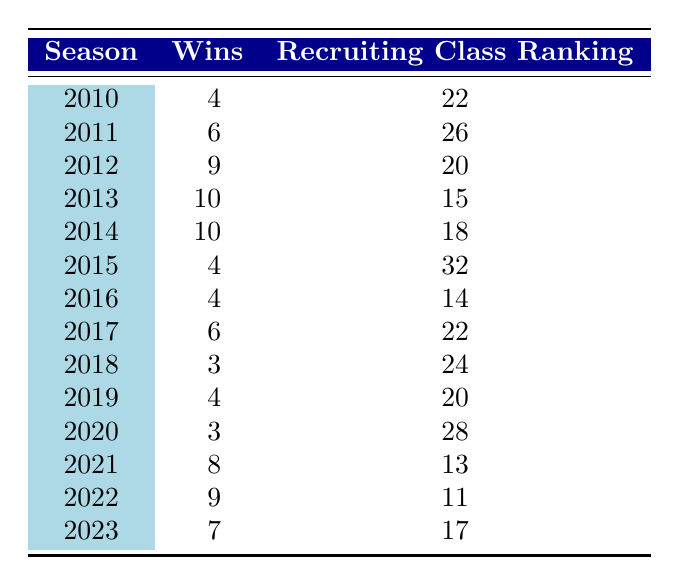What was the win count for the 2013 season? The table lists the 2013 season under the "Season" column, where the corresponding "Wins" column shows the value of 10.
Answer: 10 What season had the highest recruiting class ranking? By reviewing the "Recruiting Class Ranking" column, the lowest number (which indicates the best ranking) is 11 for the 2022 season.
Answer: 2022 How many seasons did UCLA win more than 6 games? The "Wins" column should be analyzed for values greater than 6. The seasons with wins of 7, 8, 9, and 10 are 2012, 2013, 2014, 2021, and 2022, which totals 5 seasons.
Answer: 5 What was the overall win count from 2010 to 2023? Adding the "Wins" values from each season gives the total: 4 + 6 + 9 + 10 + 10 + 4 + 4 + 6 + 3 + 4 + 3 + 8 + 9 + 7 =  81.
Answer: 81 Is it true that UCLA had a winning season (more than 6 wins) in the 2015 season? Looking at the "Wins" for 2015, it shows 4, which is not greater than 6; thus, the statement is false.
Answer: No What is the average recruiting class ranking for the seasons from 2010 to 2023? First, we sum the recruiting class rankings: 22 + 26 + 20 + 15 + 18 + 32 + 14 + 22 + 24 + 20 + 28 + 13 + 11 + 17 =  24.43. Then we divide by the total number of seasons (14) to calculate the average: 24.43 / 14 = 24.43.
Answer: 24.43 What season had the lowest win count and what was that count? The "Wins" column reveals the lowest value is 3 in both the 2018 and 2020 seasons; thus the count is 3.
Answer: 3 Which season experienced an increase in wins compared to the previous season? Comparing the "Wins" of each season to the one before it, 2011 (6) > 2010 (4), 2012 (9) > 2011 (6), 2013 (10) > 2012 (9), 2014 (10) > 2013 (10), 2021 (8) > 2020 (3), and 2022 (9) > 2021 (8), so there are 6 instances: 2011, 2012, 2013, 2014, 2021, and 2022.
Answer: 6 